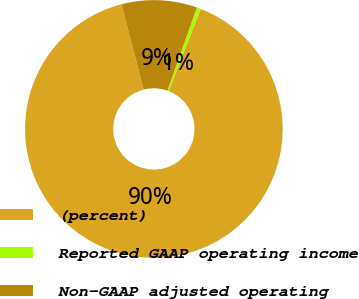Convert chart. <chart><loc_0><loc_0><loc_500><loc_500><pie_chart><fcel>(percent)<fcel>Reported GAAP operating income<fcel>Non-GAAP adjusted operating<nl><fcel>90.02%<fcel>0.51%<fcel>9.46%<nl></chart> 